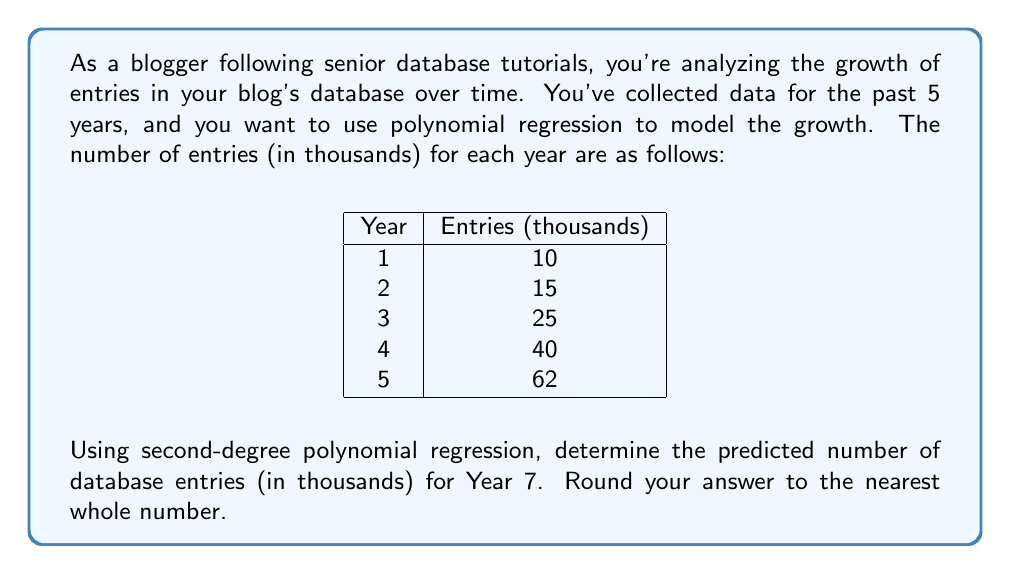Could you help me with this problem? To solve this problem, we'll use second-degree polynomial regression to fit a quadratic function to the data. The steps are as follows:

1) Our polynomial will have the form: $y = ax^2 + bx + c$, where $y$ is the number of entries and $x$ is the year (with Year 1 as $x=1$, Year 2 as $x=2$, etc.).

2) We need to solve the normal equations for quadratic regression:

   $$\begin{aligned}
   \sum y &= an + b\sum x + c\sum x^2 \\
   \sum xy &= a\sum x + b\sum x^2 + c\sum x^3 \\
   \sum x^2y &= a\sum x^2 + b\sum x^3 + c\sum x^4
   \end{aligned}$$

3) Let's calculate the sums we need:
   
   $\sum x = 1 + 2 + 3 + 4 + 5 = 15$
   $\sum x^2 = 1 + 4 + 9 + 16 + 25 = 55$
   $\sum x^3 = 1 + 8 + 27 + 64 + 125 = 225$
   $\sum x^4 = 1 + 16 + 81 + 256 + 625 = 979$
   $\sum y = 10 + 15 + 25 + 40 + 62 = 152$
   $\sum xy = 10(1) + 15(2) + 25(3) + 40(4) + 62(5) = 640$
   $\sum x^2y = 10(1) + 15(4) + 25(9) + 40(16) + 62(25) = 2870$

4) Now we can set up our system of equations:

   $$\begin{aligned}
   152 &= 5a + 15b + 55c \\
   640 &= 15a + 55b + 225c \\
   2870 &= 55a + 225b + 979c
   \end{aligned}$$

5) Solving this system (using a computer algebra system or matrix methods) gives us:

   $a \approx 1.5$
   $b \approx 3$
   $c \approx 5.5$

6) Our regression equation is therefore:

   $y \approx 1.5x^2 + 3x + 5.5$

7) To predict the number of entries for Year 7, we substitute $x=7$:

   $y \approx 1.5(7^2) + 3(7) + 5.5$
   $y \approx 1.5(49) + 21 + 5.5$
   $y \approx 73.5 + 21 + 5.5$
   $y \approx 100$

8) Rounding to the nearest whole number, we get 100.
Answer: 100 thousand entries 